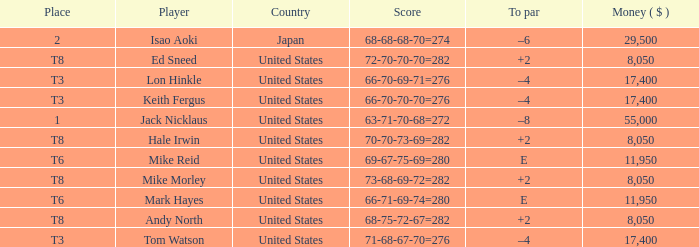Could you parse the entire table? {'header': ['Place', 'Player', 'Country', 'Score', 'To par', 'Money ( $ )'], 'rows': [['2', 'Isao Aoki', 'Japan', '68-68-68-70=274', '–6', '29,500'], ['T8', 'Ed Sneed', 'United States', '72-70-70-70=282', '+2', '8,050'], ['T3', 'Lon Hinkle', 'United States', '66-70-69-71=276', '–4', '17,400'], ['T3', 'Keith Fergus', 'United States', '66-70-70-70=276', '–4', '17,400'], ['1', 'Jack Nicklaus', 'United States', '63-71-70-68=272', '–8', '55,000'], ['T8', 'Hale Irwin', 'United States', '70-70-73-69=282', '+2', '8,050'], ['T6', 'Mike Reid', 'United States', '69-67-75-69=280', 'E', '11,950'], ['T8', 'Mike Morley', 'United States', '73-68-69-72=282', '+2', '8,050'], ['T6', 'Mark Hayes', 'United States', '66-71-69-74=280', 'E', '11,950'], ['T8', 'Andy North', 'United States', '68-75-72-67=282', '+2', '8,050'], ['T3', 'Tom Watson', 'United States', '71-68-67-70=276', '–4', '17,400']]} What player has money larger than 11,950 and is placed in t8 and has the score of 73-68-69-72=282? None. 